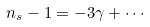<formula> <loc_0><loc_0><loc_500><loc_500>n _ { s } - 1 = - 3 \gamma + \cdots</formula> 